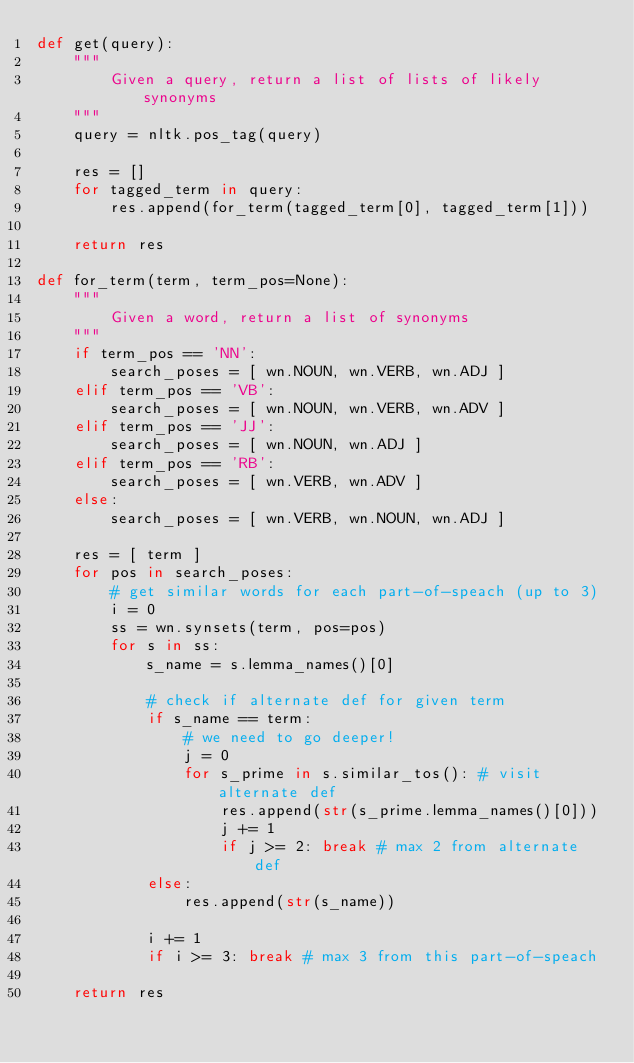Convert code to text. <code><loc_0><loc_0><loc_500><loc_500><_Python_>def get(query):
	"""
		Given a query, return a list of lists of likely synonyms
	"""
	query = nltk.pos_tag(query)

	res = []
	for tagged_term in query:
		res.append(for_term(tagged_term[0], tagged_term[1]))

	return res

def for_term(term, term_pos=None):
	"""
		Given a word, return a list of synonyms
	"""
	if term_pos == 'NN':
		search_poses = [ wn.NOUN, wn.VERB, wn.ADJ ]
	elif term_pos == 'VB':
		search_poses = [ wn.NOUN, wn.VERB, wn.ADV ]
	elif term_pos == 'JJ':
		search_poses = [ wn.NOUN, wn.ADJ ]
	elif term_pos == 'RB':
		search_poses = [ wn.VERB, wn.ADV ]
	else:
		search_poses = [ wn.VERB, wn.NOUN, wn.ADJ ]

	res = [ term ]
	for pos in search_poses:
		# get similar words for each part-of-speach (up to 3)
		i = 0
		ss = wn.synsets(term, pos=pos)
		for s in ss:
			s_name = s.lemma_names()[0]

			# check if alternate def for given term
			if s_name == term:
				# we need to go deeper!
				j = 0
				for s_prime in s.similar_tos(): # visit alternate def
					res.append(str(s_prime.lemma_names()[0]))
					j += 1
					if j >= 2: break # max 2 from alternate def
			else:
				res.append(str(s_name))

			i += 1
			if i >= 3: break # max 3 from this part-of-speach

	return res</code> 